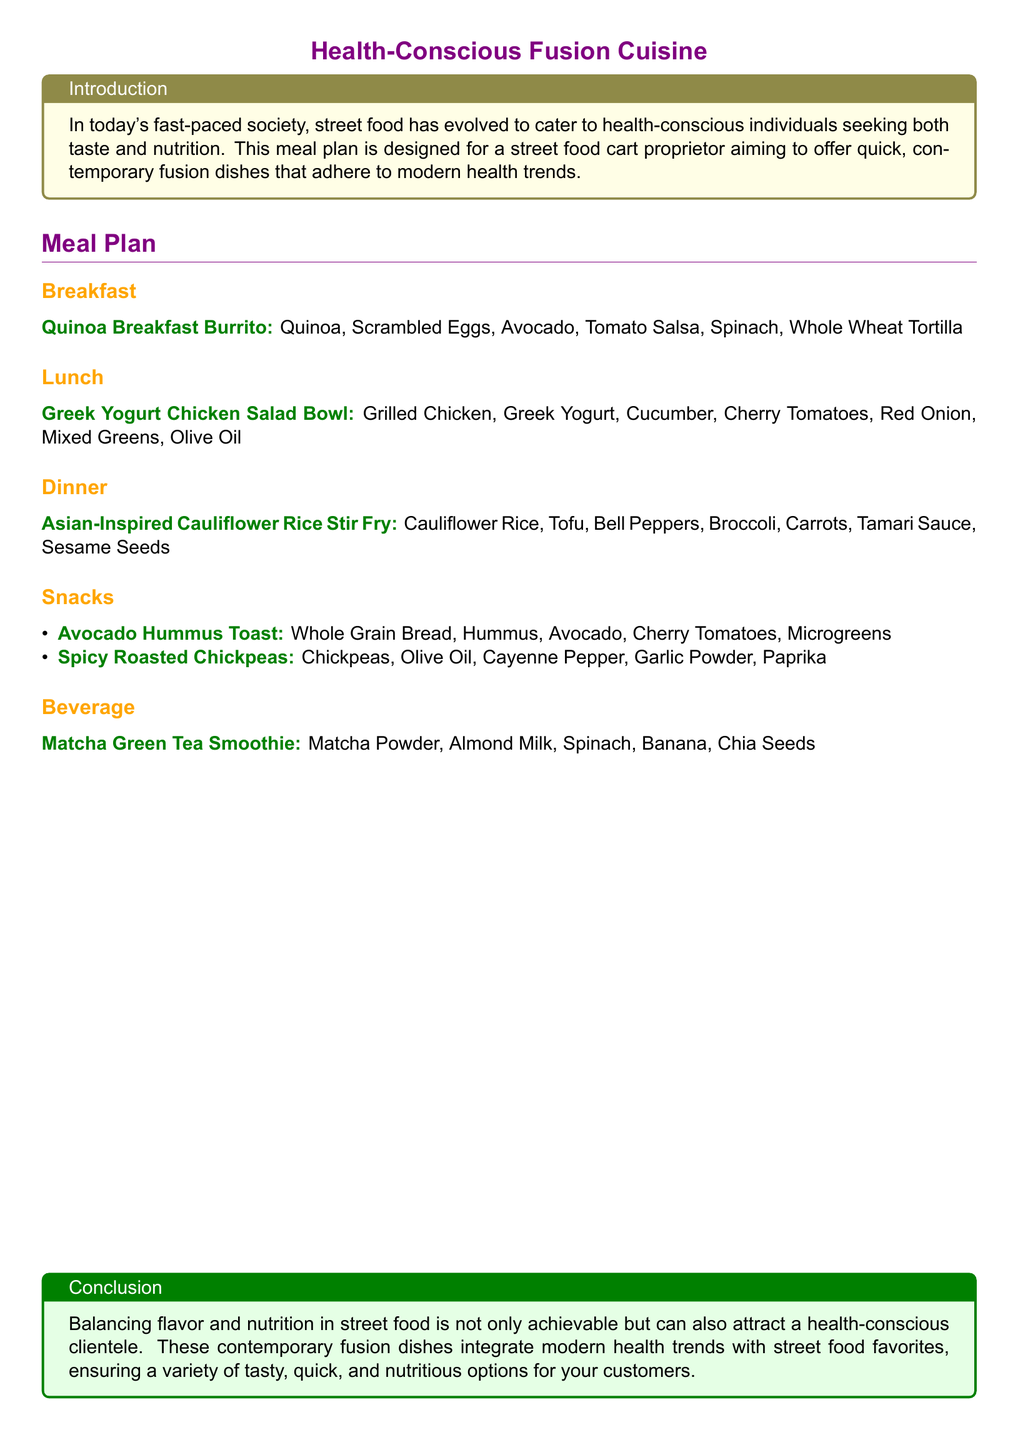What is the breakfast option? The breakfast option mentioned in the document is "Quinoa Breakfast Burrito."
Answer: Quinoa Breakfast Burrito Which ingredient is in the lunch dish? The lunch dish, "Greek Yogurt Chicken Salad Bowl," includes ingredients such as Grilled Chicken and Greek Yogurt.
Answer: Grilled Chicken What type of beverage is listed? The document provides "Matcha Green Tea Smoothie" as the beverage option.
Answer: Matcha Green Tea Smoothie How many snack options are there? The snack section lists two options: Avocado Hummus Toast and Spicy Roasted Chickpeas.
Answer: 2 What is the primary grain used in the breakfast burrito? The breakfast burrito features quinoa as its primary grain.
Answer: Quinoa Which vegetable is used in the Asian-Inspired dinner dish? The dinner dish "Asian-Inspired Cauliflower Rice Stir Fry" includes vegetables like Broccoli and Bell Peppers.
Answer: Broccoli What health trend is mentioned in the conclusion? The conclusion discusses balancing flavor and nutrition as a method to attract health-conscious clientele.
Answer: Balancing flavor and nutrition What is the primary protein source in the lunch dish? The primary protein source in the "Greek Yogurt Chicken Salad Bowl" is Grilled Chicken.
Answer: Grilled Chicken 